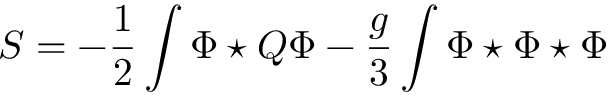<formula> <loc_0><loc_0><loc_500><loc_500>S = - \frac { 1 } { 2 } \int \Phi ^ { * } Q \Phi - \frac { g } { 3 } \int \Phi ^ { * } \Phi ^ { * } \Phi</formula> 